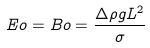Convert formula to latex. <formula><loc_0><loc_0><loc_500><loc_500>E o = B o = \frac { \Delta \rho g L ^ { 2 } } { \sigma }</formula> 